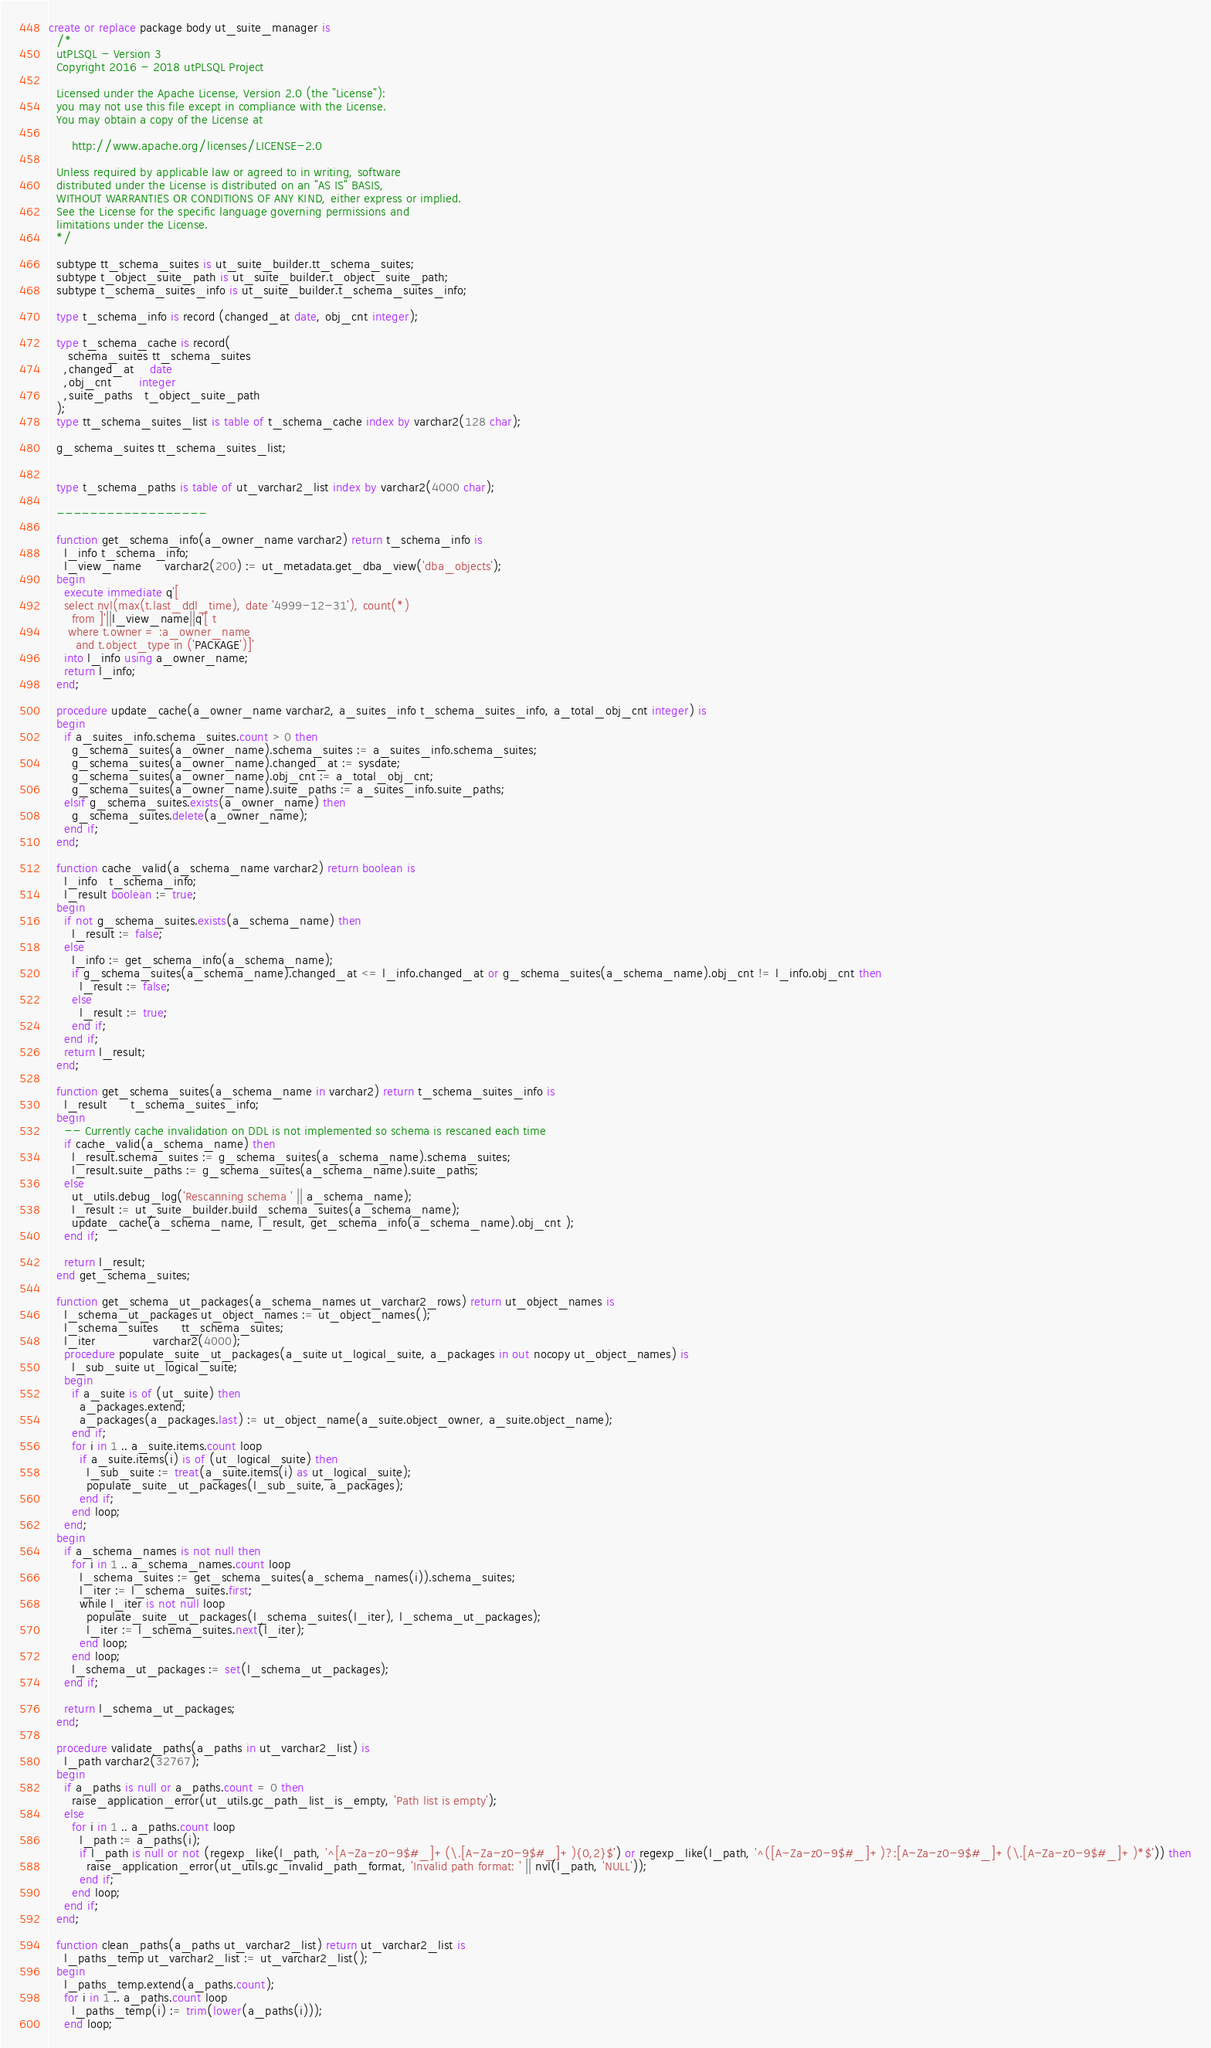Convert code to text. <code><loc_0><loc_0><loc_500><loc_500><_SQL_>create or replace package body ut_suite_manager is
  /*
  utPLSQL - Version 3
  Copyright 2016 - 2018 utPLSQL Project

  Licensed under the Apache License, Version 2.0 (the "License"):
  you may not use this file except in compliance with the License.
  You may obtain a copy of the License at

      http://www.apache.org/licenses/LICENSE-2.0

  Unless required by applicable law or agreed to in writing, software
  distributed under the License is distributed on an "AS IS" BASIS,
  WITHOUT WARRANTIES OR CONDITIONS OF ANY KIND, either express or implied.
  See the License for the specific language governing permissions and
  limitations under the License.
  */

  subtype tt_schema_suites is ut_suite_builder.tt_schema_suites;
  subtype t_object_suite_path is ut_suite_builder.t_object_suite_path;
  subtype t_schema_suites_info is ut_suite_builder.t_schema_suites_info;

  type t_schema_info is record (changed_at date, obj_cnt integer);

  type t_schema_cache is record(
     schema_suites tt_schema_suites
    ,changed_at    date
    ,obj_cnt       integer
    ,suite_paths   t_object_suite_path
  );
  type tt_schema_suites_list is table of t_schema_cache index by varchar2(128 char);

  g_schema_suites tt_schema_suites_list;


  type t_schema_paths is table of ut_varchar2_list index by varchar2(4000 char);

  ------------------

  function get_schema_info(a_owner_name varchar2) return t_schema_info is
    l_info t_schema_info;
    l_view_name      varchar2(200) := ut_metadata.get_dba_view('dba_objects');
  begin
    execute immediate q'[
    select nvl(max(t.last_ddl_time), date '4999-12-31'), count(*)
      from ]'||l_view_name||q'[ t
     where t.owner = :a_owner_name
       and t.object_type in ('PACKAGE')]'
    into l_info using a_owner_name;
    return l_info;
  end;

  procedure update_cache(a_owner_name varchar2, a_suites_info t_schema_suites_info, a_total_obj_cnt integer) is
  begin
    if a_suites_info.schema_suites.count > 0 then
      g_schema_suites(a_owner_name).schema_suites := a_suites_info.schema_suites;
      g_schema_suites(a_owner_name).changed_at := sysdate;
      g_schema_suites(a_owner_name).obj_cnt := a_total_obj_cnt;
      g_schema_suites(a_owner_name).suite_paths := a_suites_info.suite_paths;
    elsif g_schema_suites.exists(a_owner_name) then
      g_schema_suites.delete(a_owner_name);
    end if;
  end;

  function cache_valid(a_schema_name varchar2) return boolean is
    l_info   t_schema_info;
    l_result boolean := true;
  begin
    if not g_schema_suites.exists(a_schema_name) then
      l_result := false;
    else
      l_info := get_schema_info(a_schema_name);
      if g_schema_suites(a_schema_name).changed_at <= l_info.changed_at or g_schema_suites(a_schema_name).obj_cnt != l_info.obj_cnt then
        l_result := false;
      else
        l_result := true;
      end if;
    end if;
    return l_result;
  end;

  function get_schema_suites(a_schema_name in varchar2) return t_schema_suites_info is
    l_result      t_schema_suites_info;
  begin
    -- Currently cache invalidation on DDL is not implemented so schema is rescaned each time
    if cache_valid(a_schema_name) then
      l_result.schema_suites := g_schema_suites(a_schema_name).schema_suites;
      l_result.suite_paths := g_schema_suites(a_schema_name).suite_paths;
    else
      ut_utils.debug_log('Rescanning schema ' || a_schema_name);
      l_result := ut_suite_builder.build_schema_suites(a_schema_name);
      update_cache(a_schema_name, l_result, get_schema_info(a_schema_name).obj_cnt );
    end if;

    return l_result;
  end get_schema_suites;

  function get_schema_ut_packages(a_schema_names ut_varchar2_rows) return ut_object_names is
    l_schema_ut_packages ut_object_names := ut_object_names();
    l_schema_suites      tt_schema_suites;
    l_iter               varchar2(4000);
    procedure populate_suite_ut_packages(a_suite ut_logical_suite, a_packages in out nocopy ut_object_names) is
      l_sub_suite ut_logical_suite;
    begin
      if a_suite is of (ut_suite) then
        a_packages.extend;
        a_packages(a_packages.last) := ut_object_name(a_suite.object_owner, a_suite.object_name);
      end if;
      for i in 1 .. a_suite.items.count loop
        if a_suite.items(i) is of (ut_logical_suite) then
          l_sub_suite := treat(a_suite.items(i) as ut_logical_suite);
          populate_suite_ut_packages(l_sub_suite, a_packages);
        end if;
      end loop;
    end;
  begin
    if a_schema_names is not null then
      for i in 1 .. a_schema_names.count loop
        l_schema_suites := get_schema_suites(a_schema_names(i)).schema_suites;
        l_iter := l_schema_suites.first;
        while l_iter is not null loop
          populate_suite_ut_packages(l_schema_suites(l_iter), l_schema_ut_packages);
          l_iter := l_schema_suites.next(l_iter);
        end loop;
      end loop;
      l_schema_ut_packages := set(l_schema_ut_packages);
    end if;

    return l_schema_ut_packages;
  end;

  procedure validate_paths(a_paths in ut_varchar2_list) is
    l_path varchar2(32767);
  begin
    if a_paths is null or a_paths.count = 0 then
      raise_application_error(ut_utils.gc_path_list_is_empty, 'Path list is empty');
    else
      for i in 1 .. a_paths.count loop
        l_path := a_paths(i);
        if l_path is null or not (regexp_like(l_path, '^[A-Za-z0-9$#_]+(\.[A-Za-z0-9$#_]+){0,2}$') or regexp_like(l_path, '^([A-Za-z0-9$#_]+)?:[A-Za-z0-9$#_]+(\.[A-Za-z0-9$#_]+)*$')) then
          raise_application_error(ut_utils.gc_invalid_path_format, 'Invalid path format: ' || nvl(l_path, 'NULL'));
        end if;
      end loop;
    end if;
  end;

  function clean_paths(a_paths ut_varchar2_list) return ut_varchar2_list is
    l_paths_temp ut_varchar2_list := ut_varchar2_list();
  begin
    l_paths_temp.extend(a_paths.count);
    for i in 1 .. a_paths.count loop
      l_paths_temp(i) := trim(lower(a_paths(i)));
    end loop;</code> 